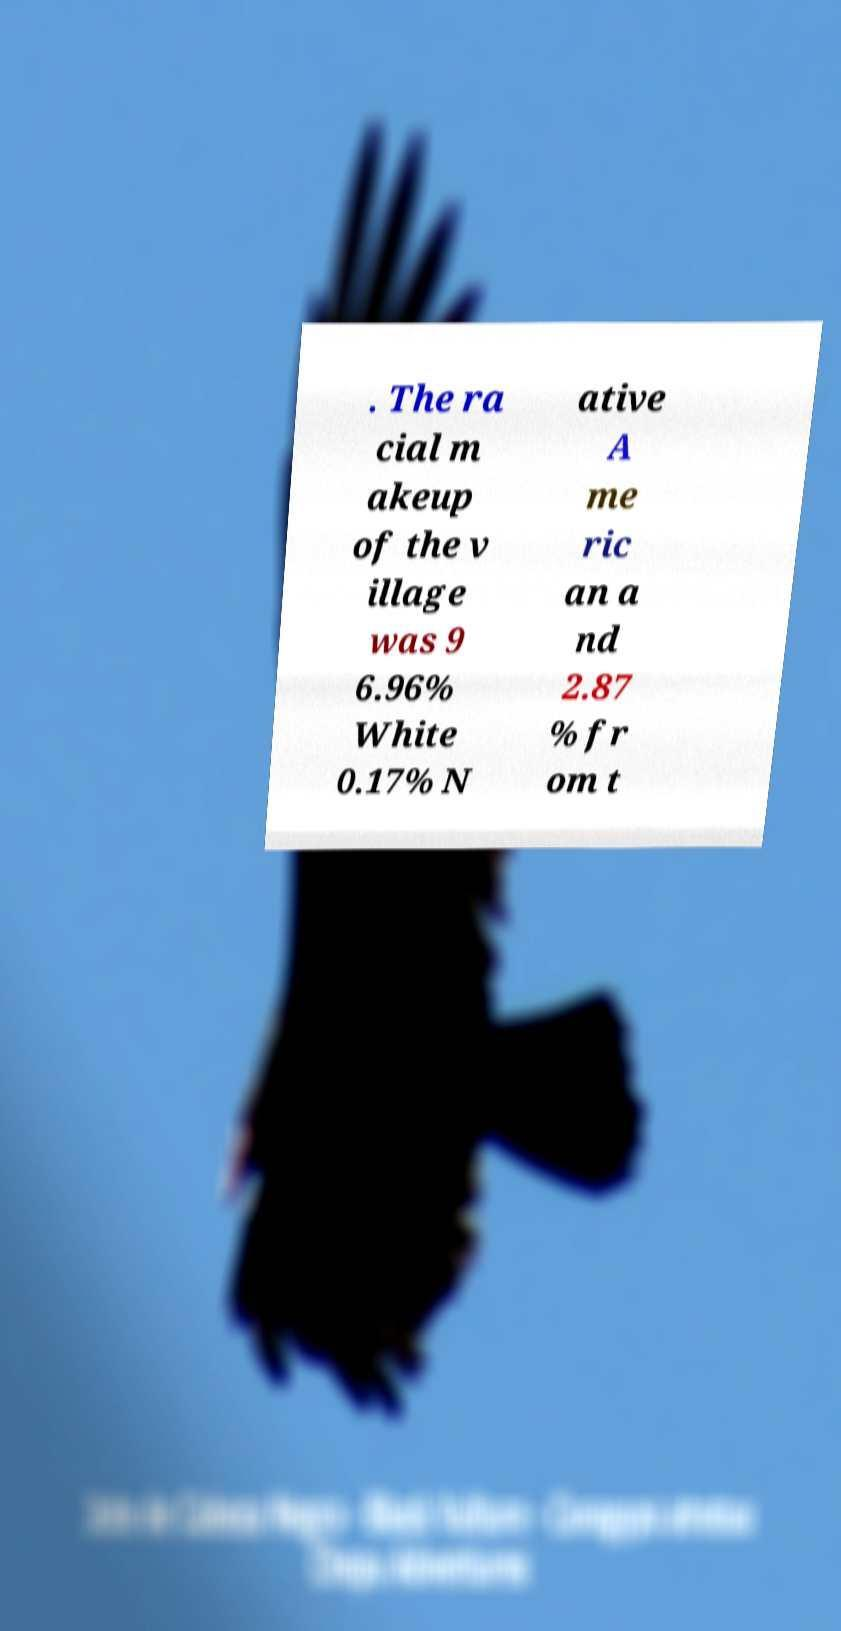Could you assist in decoding the text presented in this image and type it out clearly? . The ra cial m akeup of the v illage was 9 6.96% White 0.17% N ative A me ric an a nd 2.87 % fr om t 